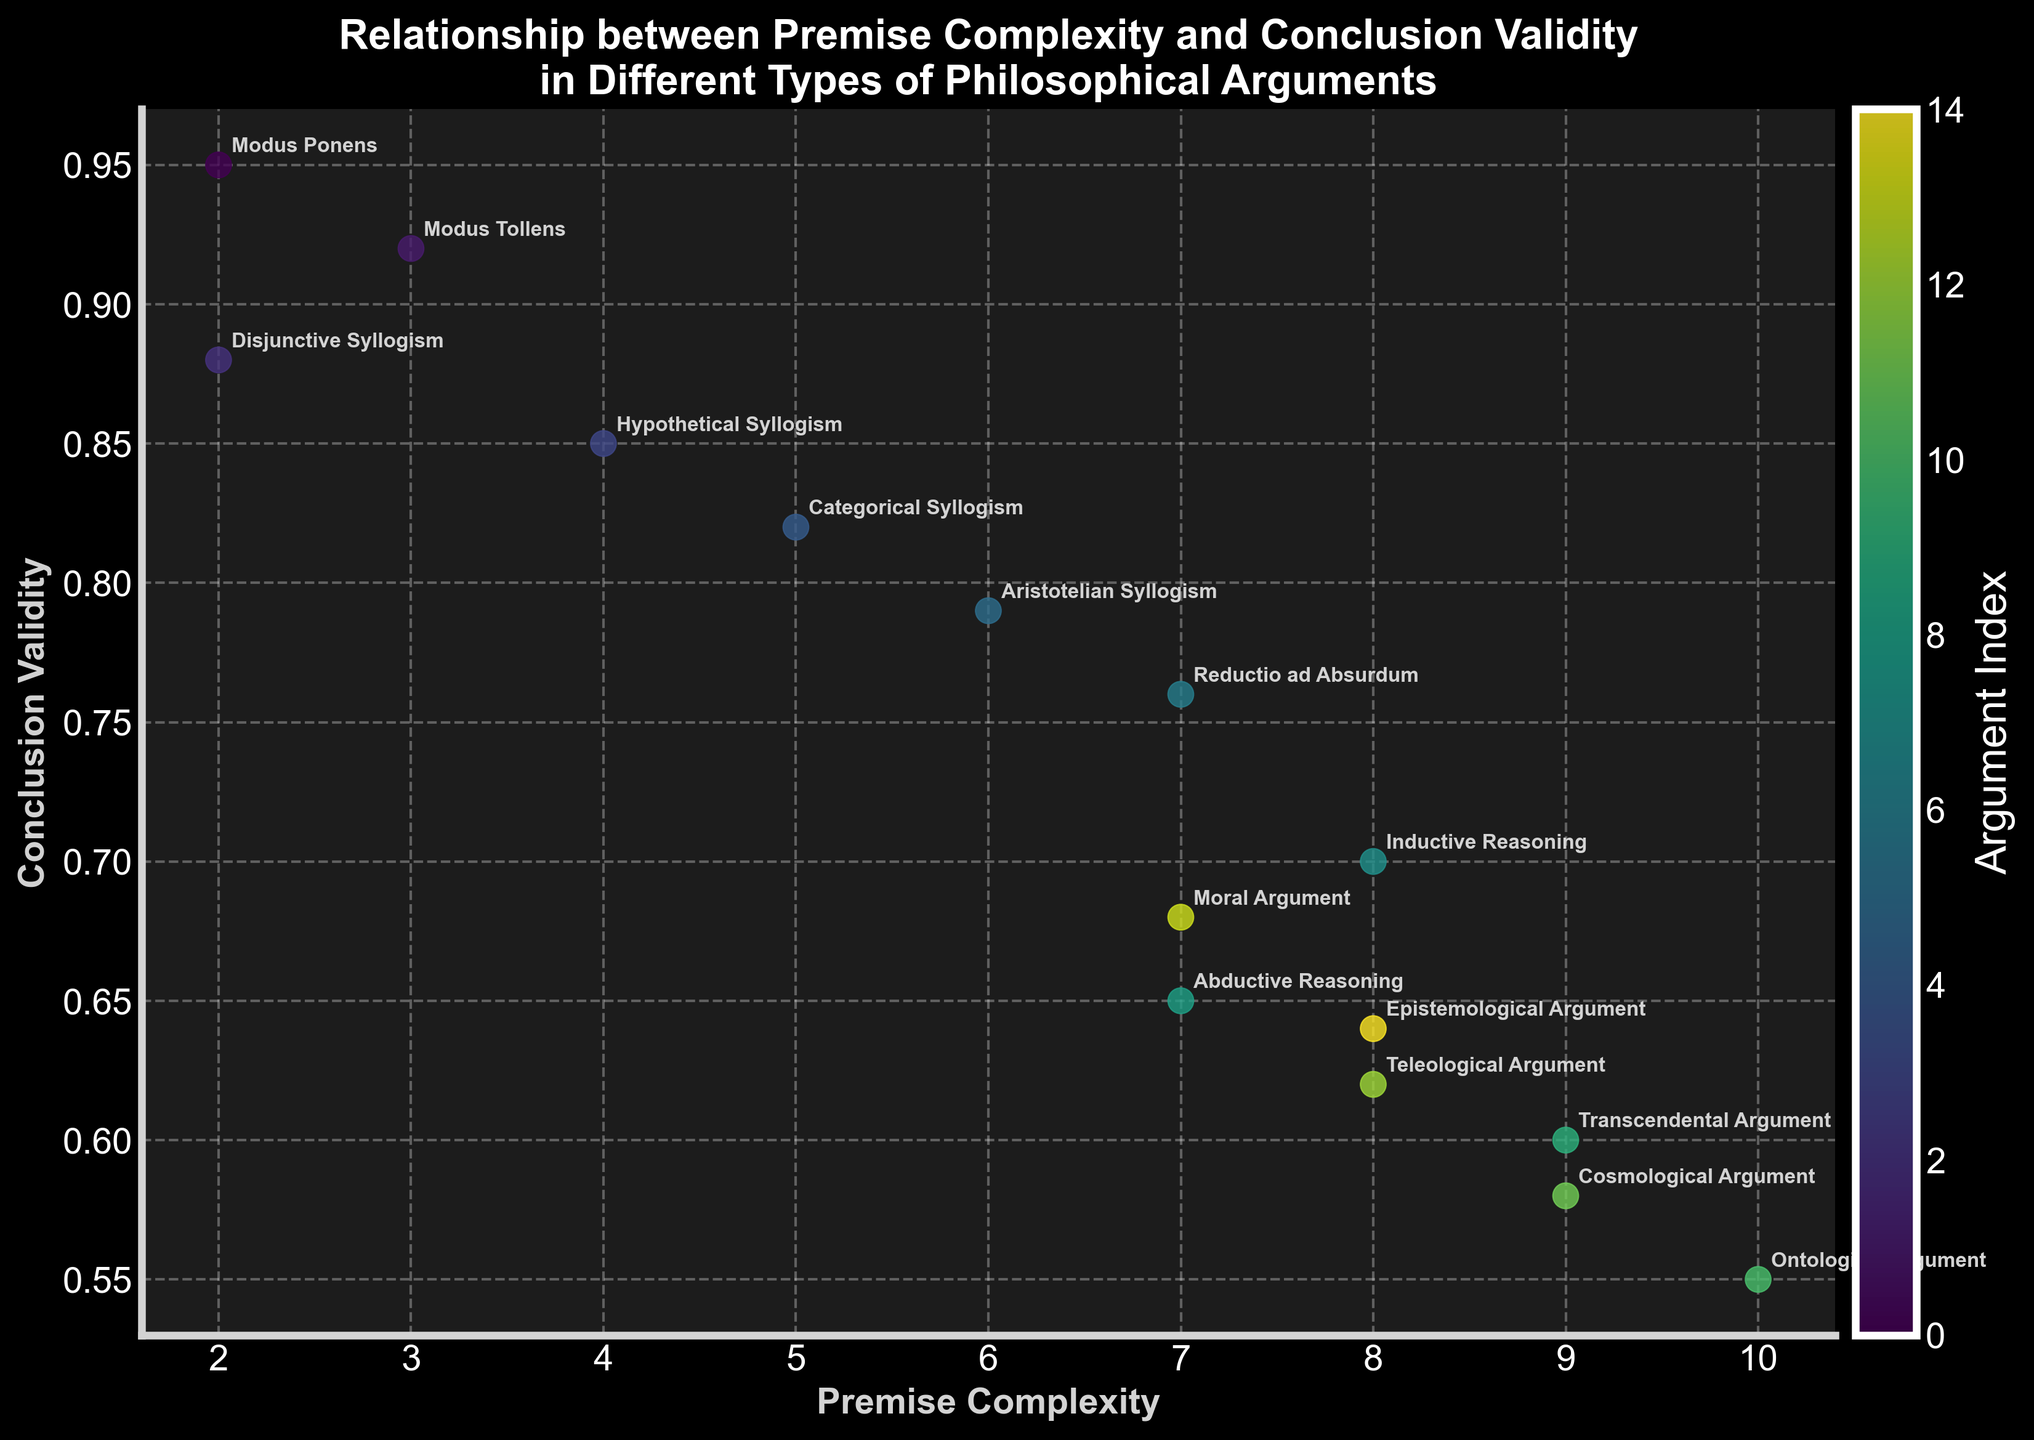What is the title of the figure? The title of the figure is displayed at the top of the plot, and it reads "Relationship between Premise Complexity and Conclusion Validity in Different Types of Philosophical Arguments."
Answer: Relationship between Premise Complexity and Conclusion Validity in Different Types of Philosophical Arguments What are the labels of the x-axis and y-axis? The labels of the axes can be seen on both the horizontal and vertical axis. The x-axis label is "Premise Complexity," and the y-axis label is "Conclusion Validity."
Answer: Premise Complexity and Conclusion Validity How many types of philosophical arguments are represented in the plot? Each point in the scatter plot represents a different type of philosophical argument, which can be identified by the text annotations. By counting these annotations, we find there are 15 types of philosophical arguments.
Answer: 15 Which argument has the highest conclusion validity and what is its premise complexity? The argument with the highest conclusion validity would be the point at the top of the plot. This point is annotated as "Modus Ponens," which has a premise complexity of 2.
Answer: Modus Ponens, 2 What is the relationship between premise complexity and conclusion validity for the "Teleological Argument"? To find this, locate the text annotation "Teleological Argument" in the plot. It corresponds to a point with a premise complexity of 8 and conclusion validity of 0.62.
Answer: Premise complexity of 8 and conclusion validity of 0.62 What is the difference in conclusion validity between "Modus Tollens" and "Abductive Reasoning"? Find both arguments in the plot: "Modus Tollens" has a conclusion validity of 0.92, and "Abductive Reasoning" has a conclusion validity of 0.65. The difference is 0.92 - 0.65.
Answer: 0.27 Is the trend between premise complexity and conclusion validity generally increasing or decreasing? By observing the scatter plot overall, as premise complexity increases, the conclusion validity tends to decrease, indicating a negative correlation.
Answer: Decreasing What is the average premise complexity of "Categorical Syllogism," "Aristotelian Syllogism," and "Transcendental Argument"? First, find the premise complexity for each: "Categorical Syllogism" is 5, "Aristotelian Syllogism" is 6, and "Transcendental Argument" is 9. The average is calculated as (5 + 6 + 9) / 3.
Answer: 6.67 Which arguments have a premise complexity greater than 7? By checking the annotated points in the plot, we find that "Inductive Reasoning," "Transcendental Argument," "Ontological Argument," "Teleological Argument," "Moral Argument," and "Epistemological Argument" all have premise complexities of 8 or more.
Answer: Inductive Reasoning, Transcendental Argument, Ontological Argument, Teleological Argument, Moral Argument, Epistemological Argument What colors are used to represent the different argument types? The scatter plot uses a colormap to differentiate argument types, seen in the range of colors from the colorbar. It typically ranges from darker (lower index) to lighter (higher index) in a 'viridis' colormap scheme.
Answer: A gradient from dark to light 